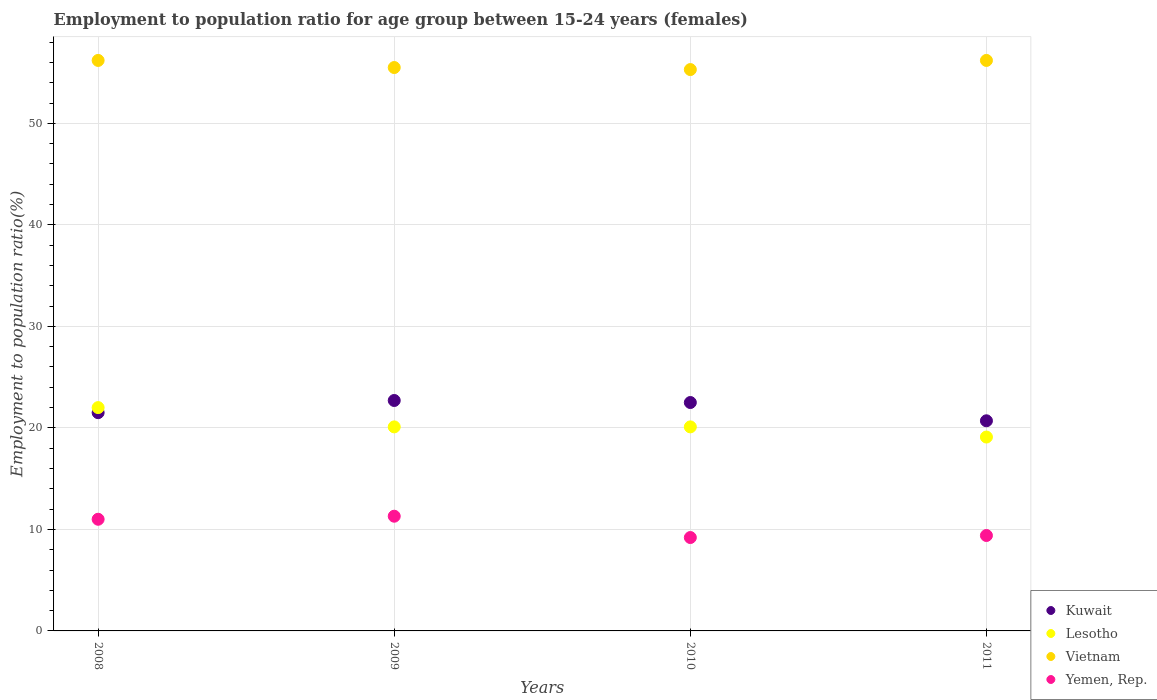Is the number of dotlines equal to the number of legend labels?
Give a very brief answer. Yes. What is the employment to population ratio in Lesotho in 2009?
Your answer should be compact. 20.1. Across all years, what is the minimum employment to population ratio in Kuwait?
Offer a terse response. 20.7. In which year was the employment to population ratio in Kuwait maximum?
Provide a succinct answer. 2009. In which year was the employment to population ratio in Yemen, Rep. minimum?
Give a very brief answer. 2010. What is the total employment to population ratio in Vietnam in the graph?
Provide a succinct answer. 223.2. What is the difference between the employment to population ratio in Lesotho in 2008 and that in 2009?
Give a very brief answer. 1.9. What is the difference between the employment to population ratio in Kuwait in 2008 and the employment to population ratio in Yemen, Rep. in 2009?
Provide a short and direct response. 10.2. What is the average employment to population ratio in Yemen, Rep. per year?
Offer a terse response. 10.22. What is the ratio of the employment to population ratio in Yemen, Rep. in 2008 to that in 2009?
Your answer should be compact. 0.97. What is the difference between the highest and the second highest employment to population ratio in Yemen, Rep.?
Make the answer very short. 0.3. What is the difference between the highest and the lowest employment to population ratio in Vietnam?
Your answer should be compact. 0.9. In how many years, is the employment to population ratio in Yemen, Rep. greater than the average employment to population ratio in Yemen, Rep. taken over all years?
Your response must be concise. 2. Is the sum of the employment to population ratio in Kuwait in 2008 and 2009 greater than the maximum employment to population ratio in Yemen, Rep. across all years?
Your response must be concise. Yes. Is it the case that in every year, the sum of the employment to population ratio in Yemen, Rep. and employment to population ratio in Lesotho  is greater than the sum of employment to population ratio in Kuwait and employment to population ratio in Vietnam?
Keep it short and to the point. Yes. Does the employment to population ratio in Lesotho monotonically increase over the years?
Your answer should be compact. No. How many dotlines are there?
Make the answer very short. 4. How many years are there in the graph?
Your answer should be very brief. 4. Does the graph contain any zero values?
Your answer should be compact. No. Does the graph contain grids?
Provide a succinct answer. Yes. Where does the legend appear in the graph?
Your answer should be compact. Bottom right. How many legend labels are there?
Offer a terse response. 4. How are the legend labels stacked?
Provide a succinct answer. Vertical. What is the title of the graph?
Offer a terse response. Employment to population ratio for age group between 15-24 years (females). What is the label or title of the X-axis?
Provide a succinct answer. Years. What is the Employment to population ratio(%) of Kuwait in 2008?
Provide a succinct answer. 21.5. What is the Employment to population ratio(%) of Vietnam in 2008?
Keep it short and to the point. 56.2. What is the Employment to population ratio(%) in Yemen, Rep. in 2008?
Your response must be concise. 11. What is the Employment to population ratio(%) of Kuwait in 2009?
Keep it short and to the point. 22.7. What is the Employment to population ratio(%) in Lesotho in 2009?
Give a very brief answer. 20.1. What is the Employment to population ratio(%) in Vietnam in 2009?
Make the answer very short. 55.5. What is the Employment to population ratio(%) of Yemen, Rep. in 2009?
Make the answer very short. 11.3. What is the Employment to population ratio(%) of Kuwait in 2010?
Provide a succinct answer. 22.5. What is the Employment to population ratio(%) in Lesotho in 2010?
Your answer should be compact. 20.1. What is the Employment to population ratio(%) of Vietnam in 2010?
Provide a short and direct response. 55.3. What is the Employment to population ratio(%) of Yemen, Rep. in 2010?
Your answer should be very brief. 9.2. What is the Employment to population ratio(%) of Kuwait in 2011?
Provide a short and direct response. 20.7. What is the Employment to population ratio(%) in Lesotho in 2011?
Keep it short and to the point. 19.1. What is the Employment to population ratio(%) in Vietnam in 2011?
Ensure brevity in your answer.  56.2. What is the Employment to population ratio(%) of Yemen, Rep. in 2011?
Make the answer very short. 9.4. Across all years, what is the maximum Employment to population ratio(%) in Kuwait?
Give a very brief answer. 22.7. Across all years, what is the maximum Employment to population ratio(%) in Lesotho?
Make the answer very short. 22. Across all years, what is the maximum Employment to population ratio(%) in Vietnam?
Offer a very short reply. 56.2. Across all years, what is the maximum Employment to population ratio(%) of Yemen, Rep.?
Your answer should be compact. 11.3. Across all years, what is the minimum Employment to population ratio(%) in Kuwait?
Keep it short and to the point. 20.7. Across all years, what is the minimum Employment to population ratio(%) of Lesotho?
Provide a succinct answer. 19.1. Across all years, what is the minimum Employment to population ratio(%) of Vietnam?
Give a very brief answer. 55.3. Across all years, what is the minimum Employment to population ratio(%) in Yemen, Rep.?
Offer a very short reply. 9.2. What is the total Employment to population ratio(%) in Kuwait in the graph?
Offer a very short reply. 87.4. What is the total Employment to population ratio(%) in Lesotho in the graph?
Your answer should be very brief. 81.3. What is the total Employment to population ratio(%) in Vietnam in the graph?
Provide a short and direct response. 223.2. What is the total Employment to population ratio(%) in Yemen, Rep. in the graph?
Your response must be concise. 40.9. What is the difference between the Employment to population ratio(%) of Kuwait in 2008 and that in 2009?
Your answer should be very brief. -1.2. What is the difference between the Employment to population ratio(%) of Vietnam in 2008 and that in 2009?
Your response must be concise. 0.7. What is the difference between the Employment to population ratio(%) of Yemen, Rep. in 2008 and that in 2009?
Make the answer very short. -0.3. What is the difference between the Employment to population ratio(%) in Kuwait in 2008 and that in 2010?
Make the answer very short. -1. What is the difference between the Employment to population ratio(%) in Lesotho in 2008 and that in 2011?
Keep it short and to the point. 2.9. What is the difference between the Employment to population ratio(%) of Kuwait in 2009 and that in 2010?
Offer a terse response. 0.2. What is the difference between the Employment to population ratio(%) of Yemen, Rep. in 2009 and that in 2010?
Keep it short and to the point. 2.1. What is the difference between the Employment to population ratio(%) in Lesotho in 2009 and that in 2011?
Provide a short and direct response. 1. What is the difference between the Employment to population ratio(%) in Vietnam in 2009 and that in 2011?
Ensure brevity in your answer.  -0.7. What is the difference between the Employment to population ratio(%) in Kuwait in 2010 and that in 2011?
Give a very brief answer. 1.8. What is the difference between the Employment to population ratio(%) of Kuwait in 2008 and the Employment to population ratio(%) of Lesotho in 2009?
Ensure brevity in your answer.  1.4. What is the difference between the Employment to population ratio(%) of Kuwait in 2008 and the Employment to population ratio(%) of Vietnam in 2009?
Make the answer very short. -34. What is the difference between the Employment to population ratio(%) in Kuwait in 2008 and the Employment to population ratio(%) in Yemen, Rep. in 2009?
Your answer should be very brief. 10.2. What is the difference between the Employment to population ratio(%) in Lesotho in 2008 and the Employment to population ratio(%) in Vietnam in 2009?
Offer a terse response. -33.5. What is the difference between the Employment to population ratio(%) of Lesotho in 2008 and the Employment to population ratio(%) of Yemen, Rep. in 2009?
Offer a very short reply. 10.7. What is the difference between the Employment to population ratio(%) of Vietnam in 2008 and the Employment to population ratio(%) of Yemen, Rep. in 2009?
Keep it short and to the point. 44.9. What is the difference between the Employment to population ratio(%) in Kuwait in 2008 and the Employment to population ratio(%) in Lesotho in 2010?
Your answer should be very brief. 1.4. What is the difference between the Employment to population ratio(%) in Kuwait in 2008 and the Employment to population ratio(%) in Vietnam in 2010?
Your response must be concise. -33.8. What is the difference between the Employment to population ratio(%) of Kuwait in 2008 and the Employment to population ratio(%) of Yemen, Rep. in 2010?
Offer a very short reply. 12.3. What is the difference between the Employment to population ratio(%) of Lesotho in 2008 and the Employment to population ratio(%) of Vietnam in 2010?
Provide a succinct answer. -33.3. What is the difference between the Employment to population ratio(%) in Vietnam in 2008 and the Employment to population ratio(%) in Yemen, Rep. in 2010?
Offer a terse response. 47. What is the difference between the Employment to population ratio(%) of Kuwait in 2008 and the Employment to population ratio(%) of Lesotho in 2011?
Your answer should be very brief. 2.4. What is the difference between the Employment to population ratio(%) in Kuwait in 2008 and the Employment to population ratio(%) in Vietnam in 2011?
Make the answer very short. -34.7. What is the difference between the Employment to population ratio(%) of Kuwait in 2008 and the Employment to population ratio(%) of Yemen, Rep. in 2011?
Give a very brief answer. 12.1. What is the difference between the Employment to population ratio(%) in Lesotho in 2008 and the Employment to population ratio(%) in Vietnam in 2011?
Give a very brief answer. -34.2. What is the difference between the Employment to population ratio(%) in Vietnam in 2008 and the Employment to population ratio(%) in Yemen, Rep. in 2011?
Offer a very short reply. 46.8. What is the difference between the Employment to population ratio(%) in Kuwait in 2009 and the Employment to population ratio(%) in Lesotho in 2010?
Provide a succinct answer. 2.6. What is the difference between the Employment to population ratio(%) in Kuwait in 2009 and the Employment to population ratio(%) in Vietnam in 2010?
Offer a terse response. -32.6. What is the difference between the Employment to population ratio(%) in Kuwait in 2009 and the Employment to population ratio(%) in Yemen, Rep. in 2010?
Ensure brevity in your answer.  13.5. What is the difference between the Employment to population ratio(%) in Lesotho in 2009 and the Employment to population ratio(%) in Vietnam in 2010?
Keep it short and to the point. -35.2. What is the difference between the Employment to population ratio(%) in Vietnam in 2009 and the Employment to population ratio(%) in Yemen, Rep. in 2010?
Offer a very short reply. 46.3. What is the difference between the Employment to population ratio(%) in Kuwait in 2009 and the Employment to population ratio(%) in Vietnam in 2011?
Provide a short and direct response. -33.5. What is the difference between the Employment to population ratio(%) of Lesotho in 2009 and the Employment to population ratio(%) of Vietnam in 2011?
Make the answer very short. -36.1. What is the difference between the Employment to population ratio(%) in Lesotho in 2009 and the Employment to population ratio(%) in Yemen, Rep. in 2011?
Your response must be concise. 10.7. What is the difference between the Employment to population ratio(%) of Vietnam in 2009 and the Employment to population ratio(%) of Yemen, Rep. in 2011?
Provide a short and direct response. 46.1. What is the difference between the Employment to population ratio(%) of Kuwait in 2010 and the Employment to population ratio(%) of Vietnam in 2011?
Offer a terse response. -33.7. What is the difference between the Employment to population ratio(%) of Kuwait in 2010 and the Employment to population ratio(%) of Yemen, Rep. in 2011?
Give a very brief answer. 13.1. What is the difference between the Employment to population ratio(%) in Lesotho in 2010 and the Employment to population ratio(%) in Vietnam in 2011?
Provide a succinct answer. -36.1. What is the difference between the Employment to population ratio(%) of Lesotho in 2010 and the Employment to population ratio(%) of Yemen, Rep. in 2011?
Offer a terse response. 10.7. What is the difference between the Employment to population ratio(%) in Vietnam in 2010 and the Employment to population ratio(%) in Yemen, Rep. in 2011?
Your answer should be compact. 45.9. What is the average Employment to population ratio(%) in Kuwait per year?
Make the answer very short. 21.85. What is the average Employment to population ratio(%) of Lesotho per year?
Ensure brevity in your answer.  20.32. What is the average Employment to population ratio(%) of Vietnam per year?
Offer a terse response. 55.8. What is the average Employment to population ratio(%) in Yemen, Rep. per year?
Your answer should be very brief. 10.22. In the year 2008, what is the difference between the Employment to population ratio(%) in Kuwait and Employment to population ratio(%) in Lesotho?
Your response must be concise. -0.5. In the year 2008, what is the difference between the Employment to population ratio(%) in Kuwait and Employment to population ratio(%) in Vietnam?
Your response must be concise. -34.7. In the year 2008, what is the difference between the Employment to population ratio(%) in Kuwait and Employment to population ratio(%) in Yemen, Rep.?
Your response must be concise. 10.5. In the year 2008, what is the difference between the Employment to population ratio(%) in Lesotho and Employment to population ratio(%) in Vietnam?
Your response must be concise. -34.2. In the year 2008, what is the difference between the Employment to population ratio(%) of Lesotho and Employment to population ratio(%) of Yemen, Rep.?
Your answer should be compact. 11. In the year 2008, what is the difference between the Employment to population ratio(%) of Vietnam and Employment to population ratio(%) of Yemen, Rep.?
Make the answer very short. 45.2. In the year 2009, what is the difference between the Employment to population ratio(%) of Kuwait and Employment to population ratio(%) of Lesotho?
Keep it short and to the point. 2.6. In the year 2009, what is the difference between the Employment to population ratio(%) in Kuwait and Employment to population ratio(%) in Vietnam?
Offer a terse response. -32.8. In the year 2009, what is the difference between the Employment to population ratio(%) in Lesotho and Employment to population ratio(%) in Vietnam?
Provide a succinct answer. -35.4. In the year 2009, what is the difference between the Employment to population ratio(%) of Lesotho and Employment to population ratio(%) of Yemen, Rep.?
Your answer should be compact. 8.8. In the year 2009, what is the difference between the Employment to population ratio(%) in Vietnam and Employment to population ratio(%) in Yemen, Rep.?
Give a very brief answer. 44.2. In the year 2010, what is the difference between the Employment to population ratio(%) of Kuwait and Employment to population ratio(%) of Vietnam?
Offer a terse response. -32.8. In the year 2010, what is the difference between the Employment to population ratio(%) of Lesotho and Employment to population ratio(%) of Vietnam?
Keep it short and to the point. -35.2. In the year 2010, what is the difference between the Employment to population ratio(%) of Vietnam and Employment to population ratio(%) of Yemen, Rep.?
Provide a short and direct response. 46.1. In the year 2011, what is the difference between the Employment to population ratio(%) of Kuwait and Employment to population ratio(%) of Vietnam?
Provide a short and direct response. -35.5. In the year 2011, what is the difference between the Employment to population ratio(%) of Kuwait and Employment to population ratio(%) of Yemen, Rep.?
Give a very brief answer. 11.3. In the year 2011, what is the difference between the Employment to population ratio(%) of Lesotho and Employment to population ratio(%) of Vietnam?
Your response must be concise. -37.1. In the year 2011, what is the difference between the Employment to population ratio(%) in Vietnam and Employment to population ratio(%) in Yemen, Rep.?
Provide a succinct answer. 46.8. What is the ratio of the Employment to population ratio(%) in Kuwait in 2008 to that in 2009?
Ensure brevity in your answer.  0.95. What is the ratio of the Employment to population ratio(%) of Lesotho in 2008 to that in 2009?
Give a very brief answer. 1.09. What is the ratio of the Employment to population ratio(%) of Vietnam in 2008 to that in 2009?
Offer a terse response. 1.01. What is the ratio of the Employment to population ratio(%) in Yemen, Rep. in 2008 to that in 2009?
Keep it short and to the point. 0.97. What is the ratio of the Employment to population ratio(%) of Kuwait in 2008 to that in 2010?
Provide a short and direct response. 0.96. What is the ratio of the Employment to population ratio(%) in Lesotho in 2008 to that in 2010?
Ensure brevity in your answer.  1.09. What is the ratio of the Employment to population ratio(%) of Vietnam in 2008 to that in 2010?
Make the answer very short. 1.02. What is the ratio of the Employment to population ratio(%) in Yemen, Rep. in 2008 to that in 2010?
Ensure brevity in your answer.  1.2. What is the ratio of the Employment to population ratio(%) in Kuwait in 2008 to that in 2011?
Offer a very short reply. 1.04. What is the ratio of the Employment to population ratio(%) in Lesotho in 2008 to that in 2011?
Give a very brief answer. 1.15. What is the ratio of the Employment to population ratio(%) in Yemen, Rep. in 2008 to that in 2011?
Provide a short and direct response. 1.17. What is the ratio of the Employment to population ratio(%) of Kuwait in 2009 to that in 2010?
Ensure brevity in your answer.  1.01. What is the ratio of the Employment to population ratio(%) of Yemen, Rep. in 2009 to that in 2010?
Make the answer very short. 1.23. What is the ratio of the Employment to population ratio(%) in Kuwait in 2009 to that in 2011?
Keep it short and to the point. 1.1. What is the ratio of the Employment to population ratio(%) in Lesotho in 2009 to that in 2011?
Make the answer very short. 1.05. What is the ratio of the Employment to population ratio(%) of Vietnam in 2009 to that in 2011?
Your answer should be compact. 0.99. What is the ratio of the Employment to population ratio(%) of Yemen, Rep. in 2009 to that in 2011?
Your response must be concise. 1.2. What is the ratio of the Employment to population ratio(%) of Kuwait in 2010 to that in 2011?
Provide a succinct answer. 1.09. What is the ratio of the Employment to population ratio(%) in Lesotho in 2010 to that in 2011?
Keep it short and to the point. 1.05. What is the ratio of the Employment to population ratio(%) in Vietnam in 2010 to that in 2011?
Your answer should be compact. 0.98. What is the ratio of the Employment to population ratio(%) of Yemen, Rep. in 2010 to that in 2011?
Provide a short and direct response. 0.98. What is the difference between the highest and the second highest Employment to population ratio(%) in Lesotho?
Your answer should be very brief. 1.9. What is the difference between the highest and the second highest Employment to population ratio(%) in Vietnam?
Your answer should be very brief. 0. What is the difference between the highest and the second highest Employment to population ratio(%) of Yemen, Rep.?
Give a very brief answer. 0.3. What is the difference between the highest and the lowest Employment to population ratio(%) of Kuwait?
Your response must be concise. 2. What is the difference between the highest and the lowest Employment to population ratio(%) of Vietnam?
Make the answer very short. 0.9. 